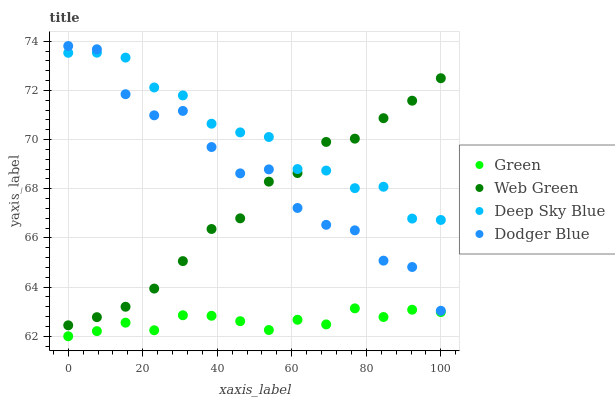Does Green have the minimum area under the curve?
Answer yes or no. Yes. Does Deep Sky Blue have the maximum area under the curve?
Answer yes or no. Yes. Does Deep Sky Blue have the minimum area under the curve?
Answer yes or no. No. Does Green have the maximum area under the curve?
Answer yes or no. No. Is Green the smoothest?
Answer yes or no. Yes. Is Dodger Blue the roughest?
Answer yes or no. Yes. Is Deep Sky Blue the smoothest?
Answer yes or no. No. Is Deep Sky Blue the roughest?
Answer yes or no. No. Does Green have the lowest value?
Answer yes or no. Yes. Does Deep Sky Blue have the lowest value?
Answer yes or no. No. Does Dodger Blue have the highest value?
Answer yes or no. Yes. Does Deep Sky Blue have the highest value?
Answer yes or no. No. Is Green less than Web Green?
Answer yes or no. Yes. Is Dodger Blue greater than Green?
Answer yes or no. Yes. Does Dodger Blue intersect Deep Sky Blue?
Answer yes or no. Yes. Is Dodger Blue less than Deep Sky Blue?
Answer yes or no. No. Is Dodger Blue greater than Deep Sky Blue?
Answer yes or no. No. Does Green intersect Web Green?
Answer yes or no. No. 